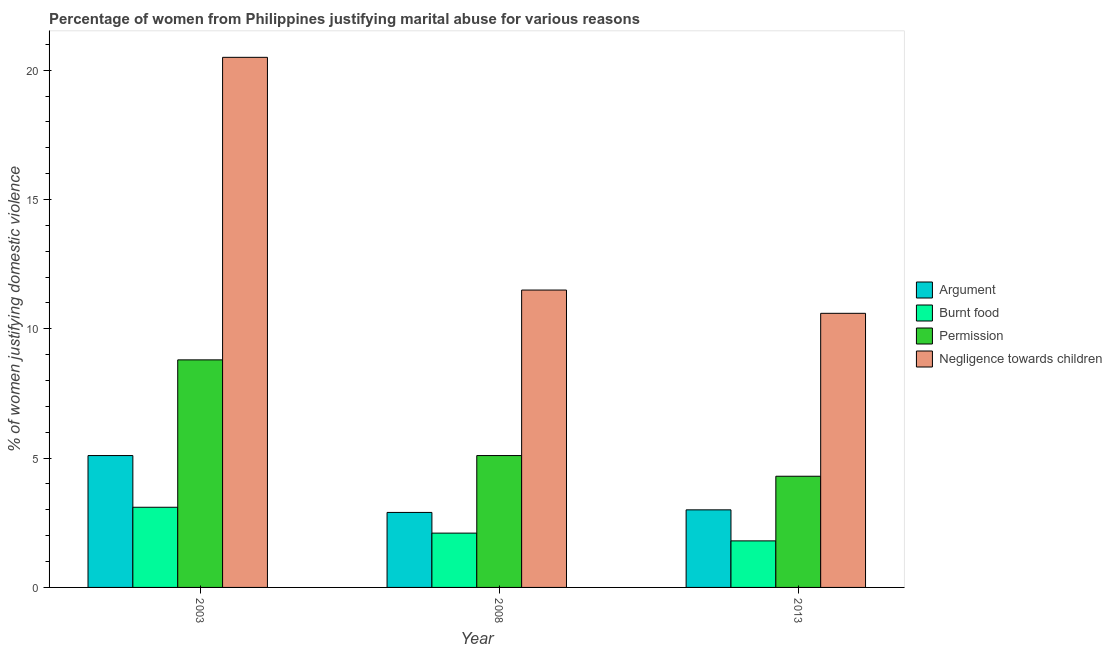How many different coloured bars are there?
Provide a succinct answer. 4. Are the number of bars per tick equal to the number of legend labels?
Ensure brevity in your answer.  Yes. How many bars are there on the 3rd tick from the left?
Provide a short and direct response. 4. How many bars are there on the 3rd tick from the right?
Your answer should be very brief. 4. In how many cases, is the number of bars for a given year not equal to the number of legend labels?
Offer a terse response. 0. What is the percentage of women justifying abuse for going without permission in 2008?
Offer a terse response. 5.1. Across all years, what is the maximum percentage of women justifying abuse in the case of an argument?
Provide a succinct answer. 5.1. Across all years, what is the minimum percentage of women justifying abuse for showing negligence towards children?
Your response must be concise. 10.6. In which year was the percentage of women justifying abuse for going without permission maximum?
Give a very brief answer. 2003. What is the difference between the percentage of women justifying abuse for going without permission in 2003 and that in 2013?
Provide a succinct answer. 4.5. What is the difference between the percentage of women justifying abuse for going without permission in 2008 and the percentage of women justifying abuse for burning food in 2003?
Keep it short and to the point. -3.7. What is the average percentage of women justifying abuse in the case of an argument per year?
Ensure brevity in your answer.  3.67. In the year 2013, what is the difference between the percentage of women justifying abuse for showing negligence towards children and percentage of women justifying abuse for going without permission?
Your response must be concise. 0. What is the ratio of the percentage of women justifying abuse for burning food in 2003 to that in 2008?
Your response must be concise. 1.48. Is the percentage of women justifying abuse for burning food in 2003 less than that in 2008?
Give a very brief answer. No. What is the difference between the highest and the second highest percentage of women justifying abuse in the case of an argument?
Offer a terse response. 2.1. What is the difference between the highest and the lowest percentage of women justifying abuse for going without permission?
Offer a terse response. 4.5. Is the sum of the percentage of women justifying abuse in the case of an argument in 2003 and 2013 greater than the maximum percentage of women justifying abuse for going without permission across all years?
Offer a terse response. Yes. Is it the case that in every year, the sum of the percentage of women justifying abuse in the case of an argument and percentage of women justifying abuse for burning food is greater than the sum of percentage of women justifying abuse for showing negligence towards children and percentage of women justifying abuse for going without permission?
Offer a very short reply. No. What does the 1st bar from the left in 2013 represents?
Offer a very short reply. Argument. What does the 4th bar from the right in 2013 represents?
Provide a succinct answer. Argument. Is it the case that in every year, the sum of the percentage of women justifying abuse in the case of an argument and percentage of women justifying abuse for burning food is greater than the percentage of women justifying abuse for going without permission?
Provide a succinct answer. No. How many bars are there?
Ensure brevity in your answer.  12. Does the graph contain any zero values?
Provide a short and direct response. No. Does the graph contain grids?
Ensure brevity in your answer.  No. Where does the legend appear in the graph?
Offer a terse response. Center right. How many legend labels are there?
Keep it short and to the point. 4. What is the title of the graph?
Your answer should be very brief. Percentage of women from Philippines justifying marital abuse for various reasons. Does "Interest Payments" appear as one of the legend labels in the graph?
Your response must be concise. No. What is the label or title of the X-axis?
Your answer should be compact. Year. What is the label or title of the Y-axis?
Offer a very short reply. % of women justifying domestic violence. What is the % of women justifying domestic violence in Permission in 2003?
Offer a terse response. 8.8. What is the % of women justifying domestic violence in Negligence towards children in 2003?
Your answer should be very brief. 20.5. What is the % of women justifying domestic violence of Argument in 2008?
Give a very brief answer. 2.9. What is the % of women justifying domestic violence of Burnt food in 2008?
Provide a short and direct response. 2.1. What is the % of women justifying domestic violence in Negligence towards children in 2008?
Keep it short and to the point. 11.5. Across all years, what is the maximum % of women justifying domestic violence in Negligence towards children?
Make the answer very short. 20.5. Across all years, what is the minimum % of women justifying domestic violence of Argument?
Your answer should be very brief. 2.9. What is the total % of women justifying domestic violence of Argument in the graph?
Offer a very short reply. 11. What is the total % of women justifying domestic violence of Burnt food in the graph?
Give a very brief answer. 7. What is the total % of women justifying domestic violence in Permission in the graph?
Your response must be concise. 18.2. What is the total % of women justifying domestic violence in Negligence towards children in the graph?
Offer a terse response. 42.6. What is the difference between the % of women justifying domestic violence in Argument in 2003 and that in 2008?
Ensure brevity in your answer.  2.2. What is the difference between the % of women justifying domestic violence in Argument in 2003 and that in 2013?
Your response must be concise. 2.1. What is the difference between the % of women justifying domestic violence in Burnt food in 2003 and that in 2013?
Provide a succinct answer. 1.3. What is the difference between the % of women justifying domestic violence in Permission in 2003 and that in 2013?
Keep it short and to the point. 4.5. What is the difference between the % of women justifying domestic violence of Argument in 2008 and that in 2013?
Keep it short and to the point. -0.1. What is the difference between the % of women justifying domestic violence in Argument in 2003 and the % of women justifying domestic violence in Permission in 2008?
Give a very brief answer. 0. What is the difference between the % of women justifying domestic violence in Argument in 2003 and the % of women justifying domestic violence in Negligence towards children in 2008?
Provide a short and direct response. -6.4. What is the difference between the % of women justifying domestic violence of Burnt food in 2003 and the % of women justifying domestic violence of Permission in 2008?
Provide a succinct answer. -2. What is the difference between the % of women justifying domestic violence of Permission in 2003 and the % of women justifying domestic violence of Negligence towards children in 2008?
Your answer should be compact. -2.7. What is the difference between the % of women justifying domestic violence in Argument in 2003 and the % of women justifying domestic violence in Burnt food in 2013?
Give a very brief answer. 3.3. What is the difference between the % of women justifying domestic violence in Argument in 2003 and the % of women justifying domestic violence in Negligence towards children in 2013?
Offer a very short reply. -5.5. What is the difference between the % of women justifying domestic violence in Burnt food in 2003 and the % of women justifying domestic violence in Negligence towards children in 2013?
Your answer should be compact. -7.5. What is the difference between the % of women justifying domestic violence in Argument in 2008 and the % of women justifying domestic violence in Burnt food in 2013?
Provide a short and direct response. 1.1. What is the difference between the % of women justifying domestic violence in Argument in 2008 and the % of women justifying domestic violence in Negligence towards children in 2013?
Your answer should be compact. -7.7. What is the difference between the % of women justifying domestic violence of Burnt food in 2008 and the % of women justifying domestic violence of Permission in 2013?
Your answer should be compact. -2.2. What is the difference between the % of women justifying domestic violence in Burnt food in 2008 and the % of women justifying domestic violence in Negligence towards children in 2013?
Your answer should be very brief. -8.5. What is the average % of women justifying domestic violence of Argument per year?
Ensure brevity in your answer.  3.67. What is the average % of women justifying domestic violence in Burnt food per year?
Offer a terse response. 2.33. What is the average % of women justifying domestic violence of Permission per year?
Keep it short and to the point. 6.07. In the year 2003, what is the difference between the % of women justifying domestic violence in Argument and % of women justifying domestic violence in Burnt food?
Give a very brief answer. 2. In the year 2003, what is the difference between the % of women justifying domestic violence in Argument and % of women justifying domestic violence in Negligence towards children?
Your response must be concise. -15.4. In the year 2003, what is the difference between the % of women justifying domestic violence of Burnt food and % of women justifying domestic violence of Permission?
Make the answer very short. -5.7. In the year 2003, what is the difference between the % of women justifying domestic violence of Burnt food and % of women justifying domestic violence of Negligence towards children?
Offer a terse response. -17.4. In the year 2003, what is the difference between the % of women justifying domestic violence in Permission and % of women justifying domestic violence in Negligence towards children?
Ensure brevity in your answer.  -11.7. In the year 2008, what is the difference between the % of women justifying domestic violence in Argument and % of women justifying domestic violence in Permission?
Your answer should be very brief. -2.2. In the year 2008, what is the difference between the % of women justifying domestic violence of Burnt food and % of women justifying domestic violence of Permission?
Provide a succinct answer. -3. In the year 2008, what is the difference between the % of women justifying domestic violence in Burnt food and % of women justifying domestic violence in Negligence towards children?
Your response must be concise. -9.4. In the year 2013, what is the difference between the % of women justifying domestic violence in Permission and % of women justifying domestic violence in Negligence towards children?
Your answer should be compact. -6.3. What is the ratio of the % of women justifying domestic violence of Argument in 2003 to that in 2008?
Provide a short and direct response. 1.76. What is the ratio of the % of women justifying domestic violence in Burnt food in 2003 to that in 2008?
Provide a short and direct response. 1.48. What is the ratio of the % of women justifying domestic violence of Permission in 2003 to that in 2008?
Give a very brief answer. 1.73. What is the ratio of the % of women justifying domestic violence in Negligence towards children in 2003 to that in 2008?
Ensure brevity in your answer.  1.78. What is the ratio of the % of women justifying domestic violence in Argument in 2003 to that in 2013?
Your answer should be very brief. 1.7. What is the ratio of the % of women justifying domestic violence in Burnt food in 2003 to that in 2013?
Provide a succinct answer. 1.72. What is the ratio of the % of women justifying domestic violence of Permission in 2003 to that in 2013?
Keep it short and to the point. 2.05. What is the ratio of the % of women justifying domestic violence in Negligence towards children in 2003 to that in 2013?
Give a very brief answer. 1.93. What is the ratio of the % of women justifying domestic violence in Argument in 2008 to that in 2013?
Your answer should be compact. 0.97. What is the ratio of the % of women justifying domestic violence of Burnt food in 2008 to that in 2013?
Offer a very short reply. 1.17. What is the ratio of the % of women justifying domestic violence in Permission in 2008 to that in 2013?
Ensure brevity in your answer.  1.19. What is the ratio of the % of women justifying domestic violence in Negligence towards children in 2008 to that in 2013?
Provide a succinct answer. 1.08. What is the difference between the highest and the second highest % of women justifying domestic violence in Argument?
Give a very brief answer. 2.1. What is the difference between the highest and the second highest % of women justifying domestic violence of Burnt food?
Give a very brief answer. 1. What is the difference between the highest and the second highest % of women justifying domestic violence in Permission?
Your answer should be compact. 3.7. What is the difference between the highest and the second highest % of women justifying domestic violence of Negligence towards children?
Provide a succinct answer. 9. What is the difference between the highest and the lowest % of women justifying domestic violence in Permission?
Give a very brief answer. 4.5. What is the difference between the highest and the lowest % of women justifying domestic violence in Negligence towards children?
Your response must be concise. 9.9. 